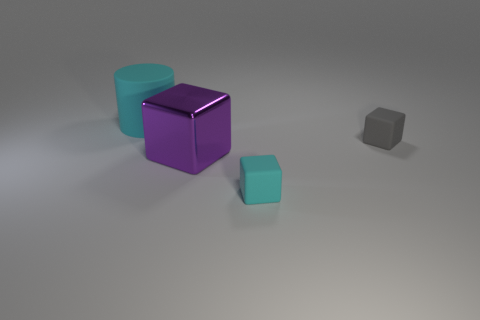There is a cyan object that is the same size as the gray object; what shape is it?
Offer a terse response. Cube. Is the number of purple metallic things behind the big purple block the same as the number of cubes behind the cyan block?
Your answer should be compact. No. Is there anything else that has the same shape as the big cyan object?
Your answer should be compact. No. Is the tiny cube behind the small cyan rubber thing made of the same material as the big cyan cylinder?
Ensure brevity in your answer.  Yes. There is a object that is the same size as the cylinder; what material is it?
Provide a succinct answer. Metal. How many other things are the same material as the big cylinder?
Your answer should be very brief. 2. Does the matte cylinder have the same size as the cyan thing that is in front of the large cyan rubber cylinder?
Ensure brevity in your answer.  No. Is the number of big cyan objects behind the gray rubber cube less than the number of tiny matte cubes that are right of the big cyan rubber object?
Make the answer very short. Yes. What size is the cyan matte thing in front of the small gray rubber block?
Ensure brevity in your answer.  Small. Do the cyan matte cylinder and the purple shiny cube have the same size?
Make the answer very short. Yes. 